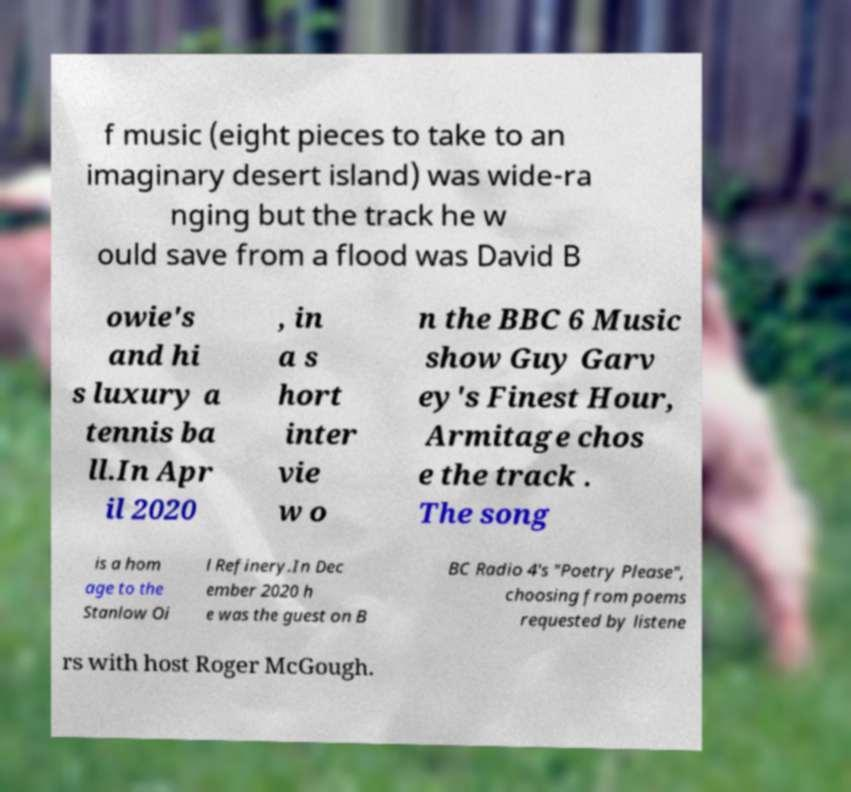Could you extract and type out the text from this image? f music (eight pieces to take to an imaginary desert island) was wide-ra nging but the track he w ould save from a flood was David B owie's and hi s luxury a tennis ba ll.In Apr il 2020 , in a s hort inter vie w o n the BBC 6 Music show Guy Garv ey's Finest Hour, Armitage chos e the track . The song is a hom age to the Stanlow Oi l Refinery.In Dec ember 2020 h e was the guest on B BC Radio 4's "Poetry Please", choosing from poems requested by listene rs with host Roger McGough. 